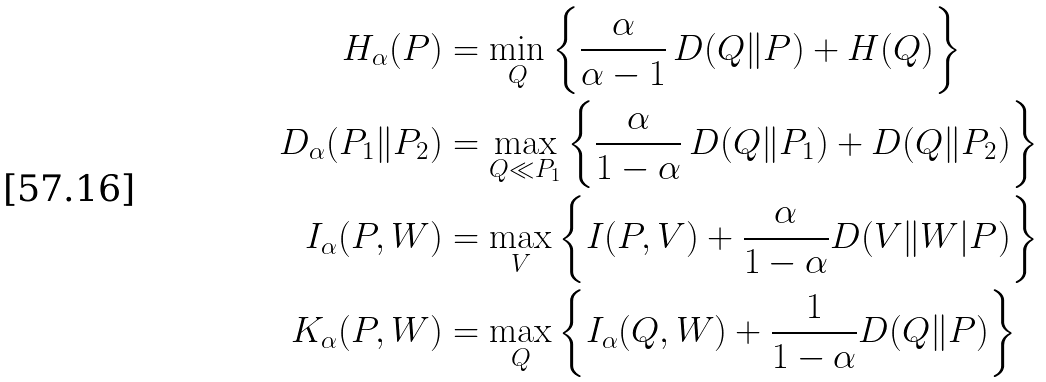<formula> <loc_0><loc_0><loc_500><loc_500>H _ { \alpha } ( P ) & = \min _ { Q } \left \{ \frac { \alpha } { \alpha - 1 } \, D ( Q \| P ) + H ( Q ) \right \} \\ D _ { \alpha } ( P _ { 1 } \| P _ { 2 } ) & = \max _ { Q \ll P _ { 1 } } \left \{ \frac { \alpha } { 1 - \alpha } \, D ( Q \| P _ { 1 } ) + D ( Q \| P _ { 2 } ) \right \} \\ I _ { \alpha } ( P , W ) & = \max _ { V } \left \{ I ( P , V ) + \frac { \alpha } { 1 - \alpha } D ( V \| W | P ) \right \} \\ K _ { \alpha } ( P , W ) & = \max _ { Q } \left \{ I _ { \alpha } ( Q , W ) + \frac { 1 } { 1 - \alpha } D ( Q \| P ) \right \}</formula> 